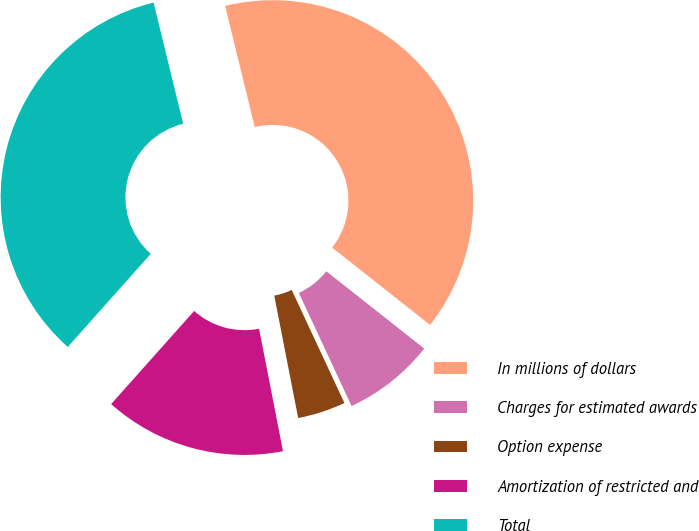<chart> <loc_0><loc_0><loc_500><loc_500><pie_chart><fcel>In millions of dollars<fcel>Charges for estimated awards<fcel>Option expense<fcel>Amortization of restricted and<fcel>Total<nl><fcel>39.45%<fcel>7.42%<fcel>3.87%<fcel>14.66%<fcel>34.6%<nl></chart> 